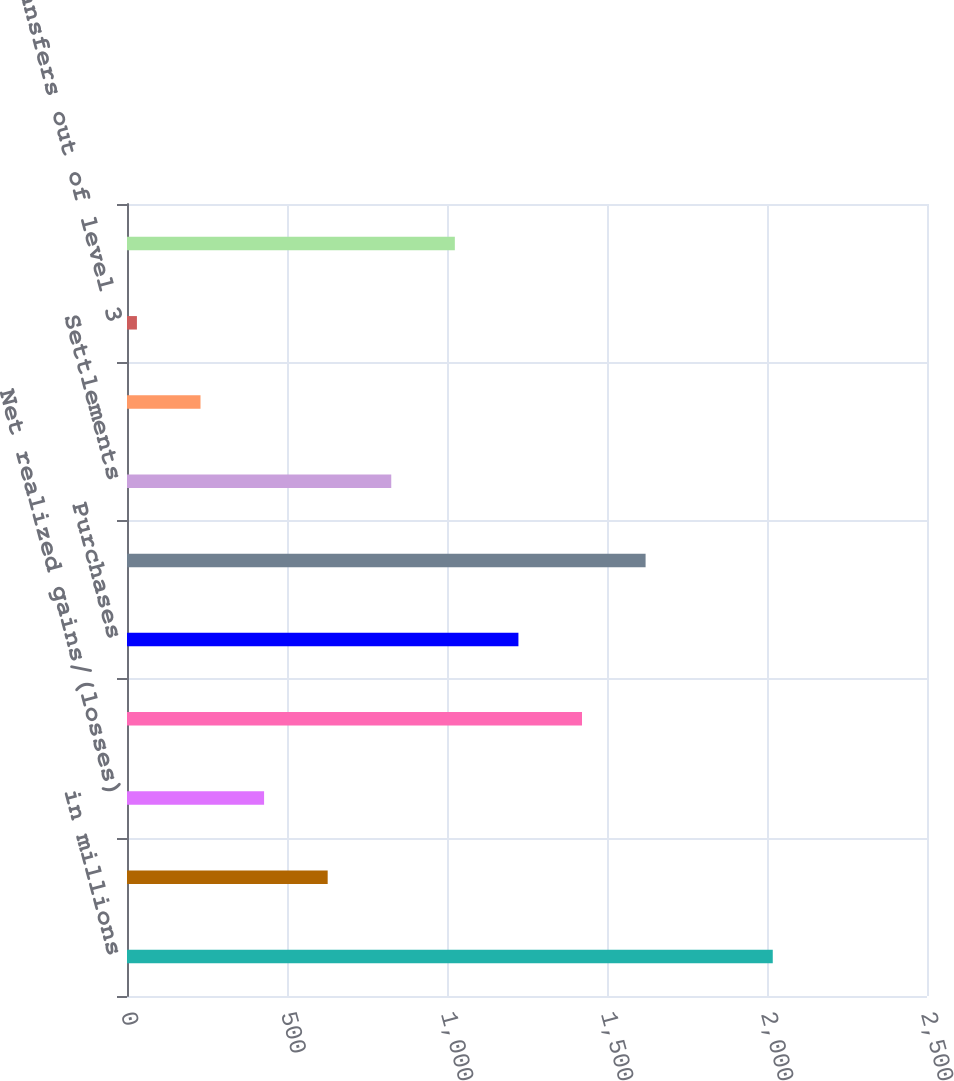Convert chart. <chart><loc_0><loc_0><loc_500><loc_500><bar_chart><fcel>in millions<fcel>Beginning balance<fcel>Net realized gains/(losses)<fcel>Net unrealized gains/(losses)<fcel>Purchases<fcel>Sales<fcel>Settlements<fcel>Transfers into level 3<fcel>Transfers out of level 3<fcel>Ending balance<nl><fcel>2018<fcel>627.1<fcel>428.4<fcel>1421.9<fcel>1223.2<fcel>1620.6<fcel>825.8<fcel>229.7<fcel>31<fcel>1024.5<nl></chart> 